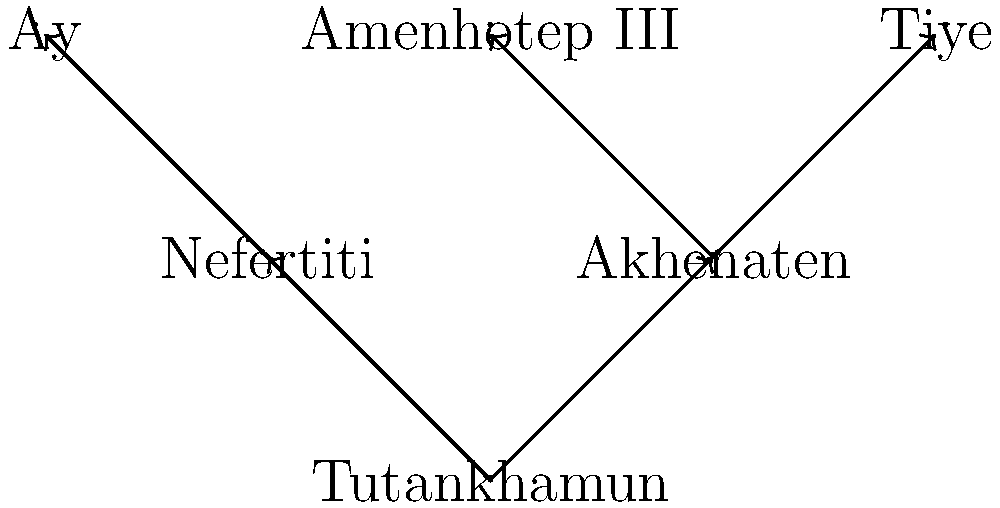In the family tree of Egyptian pharaohs shown above, which individual is not directly related to Tutankhamun by blood, but played a significant role in his life and reign? To answer this question, we need to analyze the family tree and understand the relationships between the individuals:

1. Tutankhamun is at the bottom of the tree, connected to Akhenaten and Nefertiti.
2. Akhenaten is Tutankhamun's father, connected to Amenhotep III and Tiye (Tutankhamun's grandparents).
3. Nefertiti is shown as Tutankhamun's mother in this simplified tree.
4. Ay is connected only to Nefertiti, indicating he is not directly related to Tutankhamun by blood.

Historically, Ay was an influential figure during Tutankhamun's reign:
1. He served as a vizier and advisor to Tutankhamun.
2. Ay became pharaoh after Tutankhamun's death, likely due to his political influence.
3. Some theories suggest Ay may have been Nefertiti's father, making him Tutankhamun's grandfather-in-law.

Despite his significance, Ay is not directly related to Tutankhamun by blood according to this family tree and most historical accounts.
Answer: Ay 